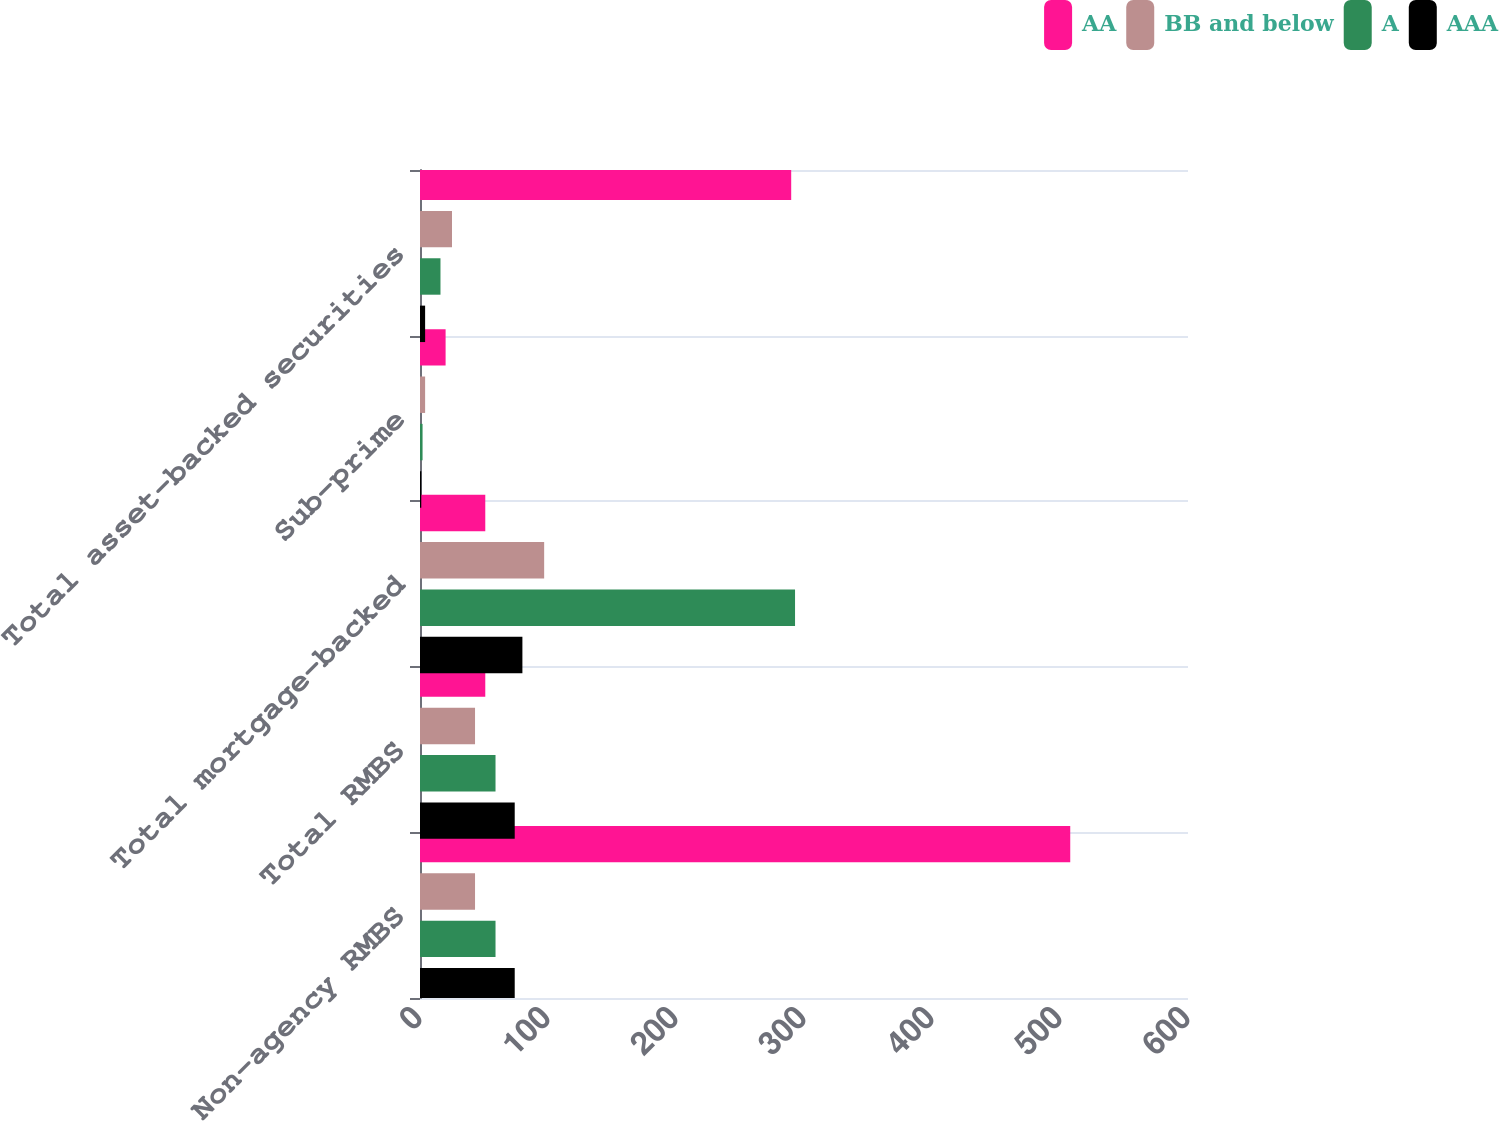Convert chart. <chart><loc_0><loc_0><loc_500><loc_500><stacked_bar_chart><ecel><fcel>Non-agency RMBS<fcel>Total RMBS<fcel>Total mortgage-backed<fcel>Sub-prime<fcel>Total asset-backed securities<nl><fcel>AA<fcel>508<fcel>51<fcel>51<fcel>20<fcel>290<nl><fcel>BB and below<fcel>43<fcel>43<fcel>97<fcel>4<fcel>25<nl><fcel>A<fcel>59<fcel>59<fcel>293<fcel>2<fcel>16<nl><fcel>AAA<fcel>74<fcel>74<fcel>80<fcel>1<fcel>4<nl></chart> 